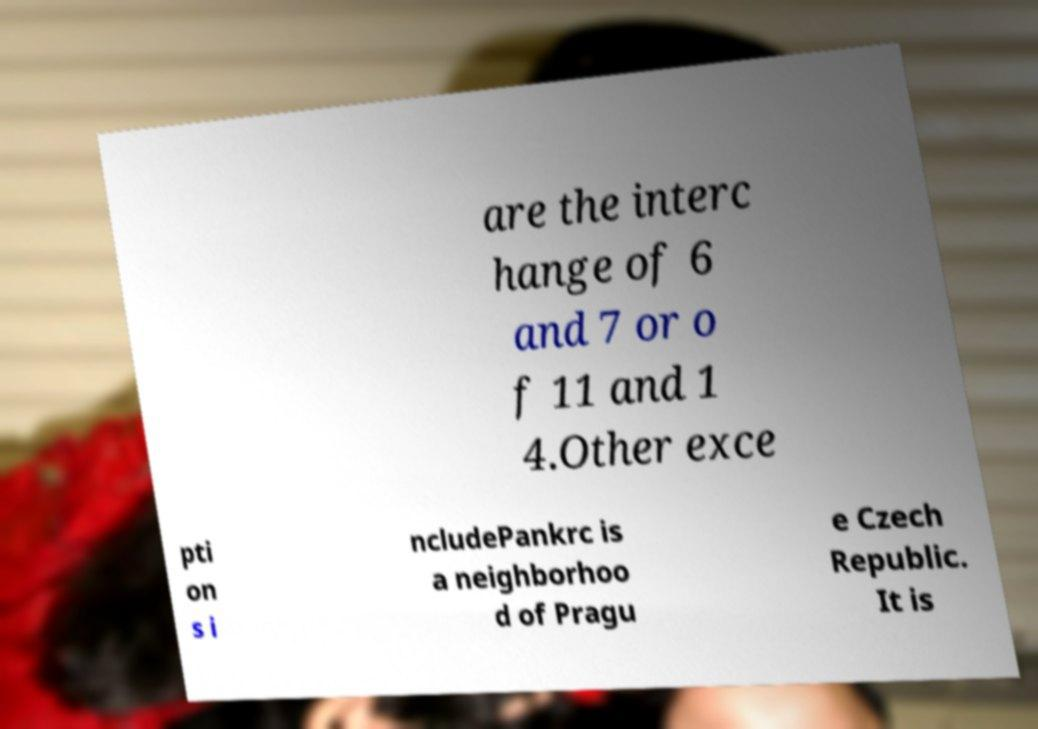Please read and relay the text visible in this image. What does it say? are the interc hange of 6 and 7 or o f 11 and 1 4.Other exce pti on s i ncludePankrc is a neighborhoo d of Pragu e Czech Republic. It is 